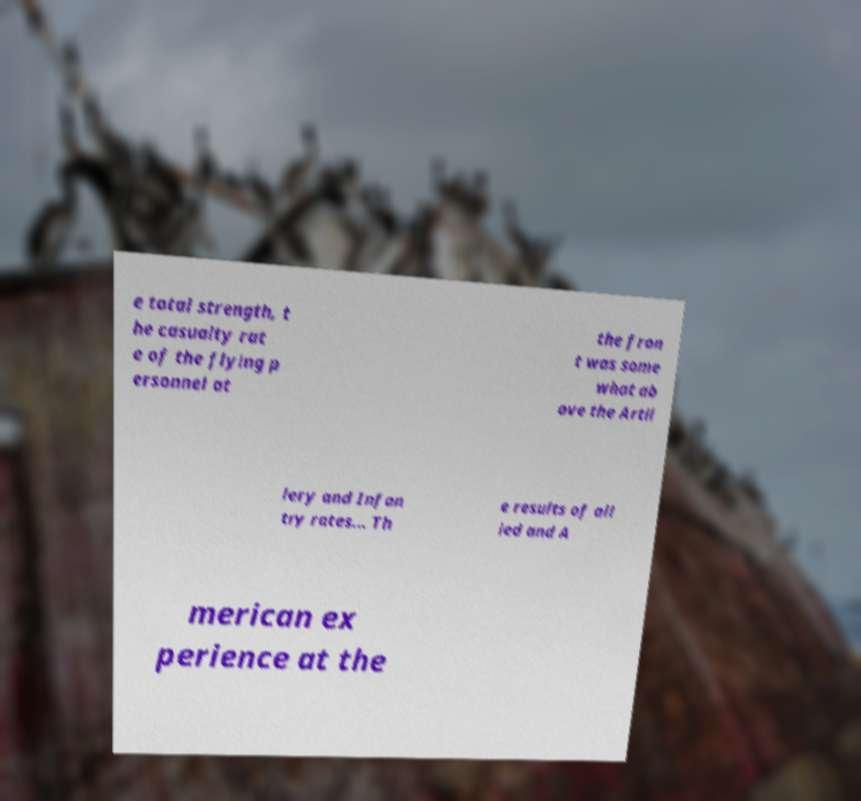Could you extract and type out the text from this image? e total strength, t he casualty rat e of the flying p ersonnel at the fron t was some what ab ove the Artil lery and Infan try rates... Th e results of all ied and A merican ex perience at the 